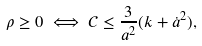Convert formula to latex. <formula><loc_0><loc_0><loc_500><loc_500>\rho \geq 0 \iff \mathcal { C } \leq \frac { 3 } { a ^ { 2 } } ( k + \dot { a } ^ { 2 } ) ,</formula> 